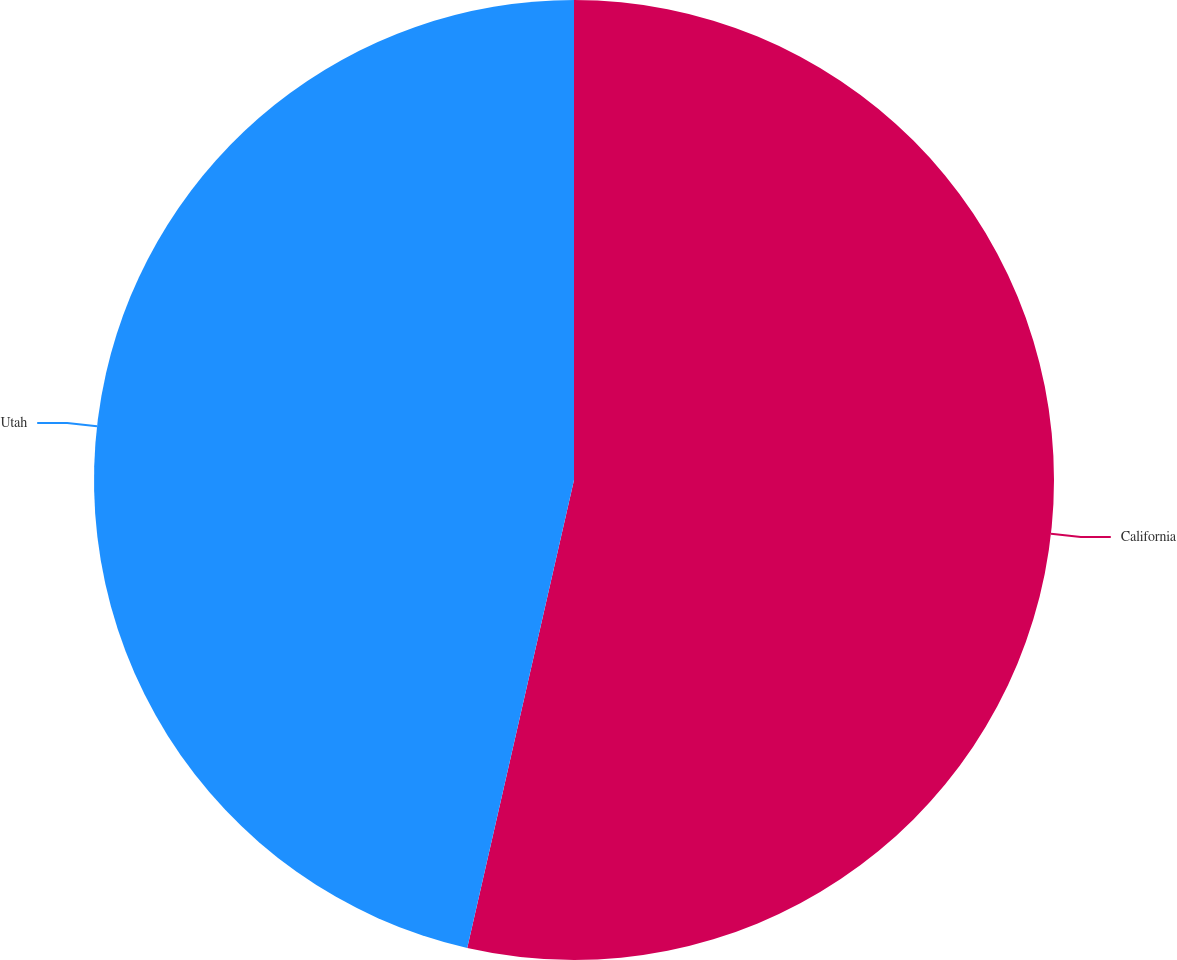Convert chart. <chart><loc_0><loc_0><loc_500><loc_500><pie_chart><fcel>California<fcel>Utah<nl><fcel>53.57%<fcel>46.43%<nl></chart> 